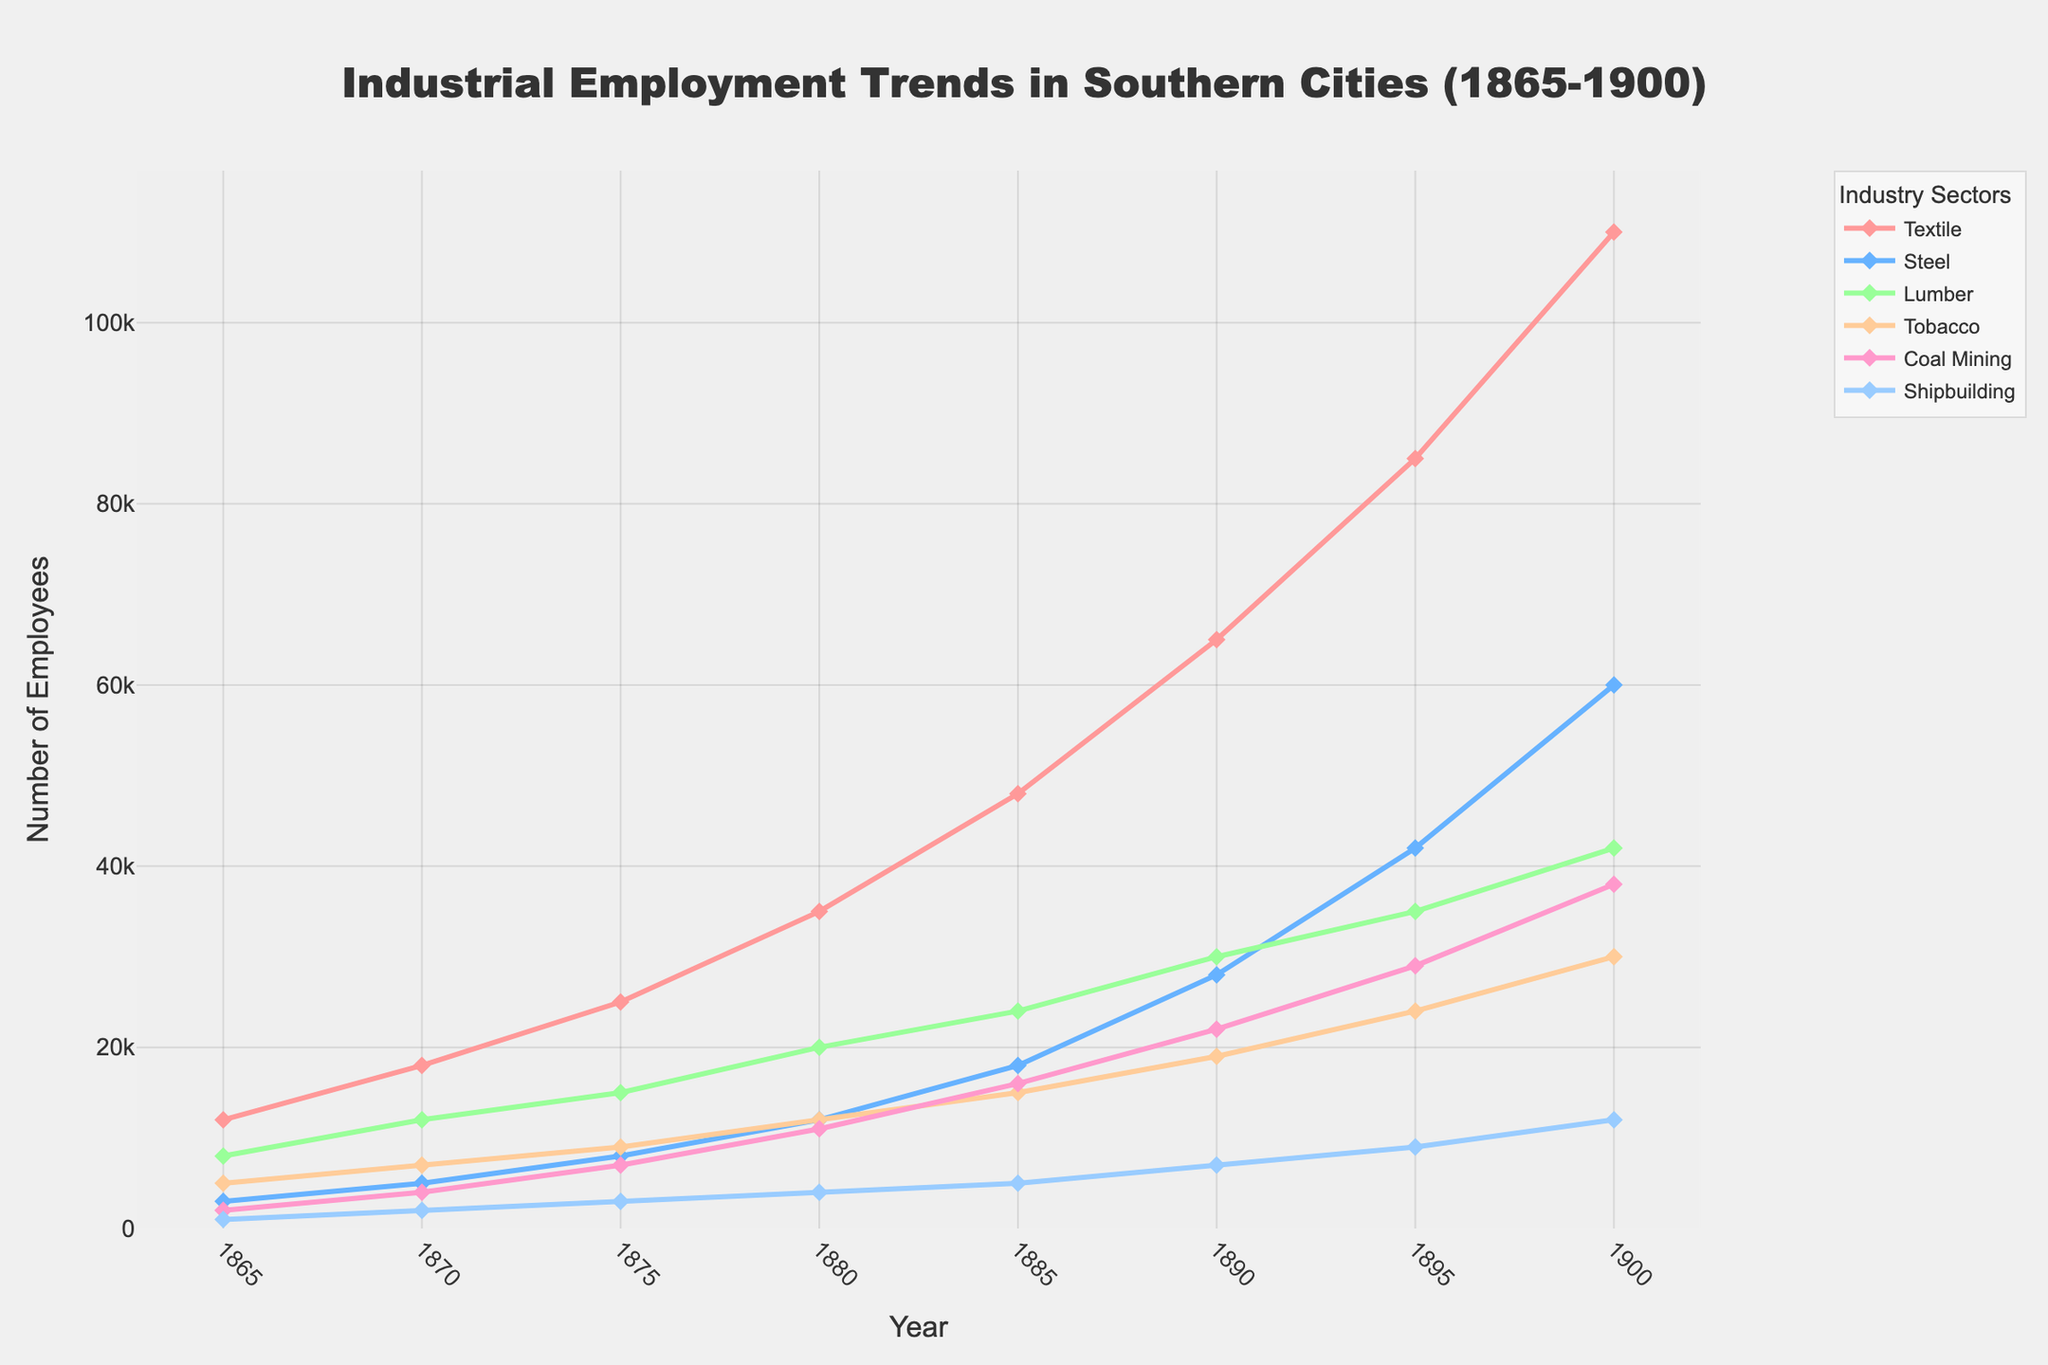What's the difference in the number of Textile and Lumber employees in 1900? In the year 1900, the Textile sector had 110,000 employees, and the Lumber sector had 42,000 employees. The difference is calculated as 110,000 - 42,000 = 68,000.
Answer: 68,000 Which sector saw the largest increase in employment from 1865 to 1900? To determine the sector with the largest increase, we subtract the 1865 employment numbers from the 1900 employment numbers for each sector. Textile: 110,000 - 12,000 = 98,000; Steel: 60,000 - 3,000 = 57,000; Lumber: 42,000 - 8,000 = 34,000; Tobacco: 30,000 - 5,000 = 25,000; Coal Mining: 38,000 - 2,000 = 36,000; Shipbuilding: 12,000 - 1,000 = 11,000. The Textile sector saw the largest increase of 98,000.
Answer: Textile During which decade did the Textile sector experience the most rapid growth? To find the decade with the most rapid growth, we look at the increase in employment numbers for each decade. 1865-1870: 18,000 - 12,000 = 6,000; 1870-1880: 35,000 - 18,000 = 17,000; 1880-1890: 65,000 - 35,000 = 30,000; 1890-1900: 110,000 - 65,000 = 45,000. The Textile sector saw the most rapid growth during the 1890-1900 decade with an increase of 45,000.
Answer: 1890-1900 How many more employees were there in the Steel sector than in the Coal Mining sector in 1890? In 1890, the Steel sector had 28,000 employees, and the Coal Mining sector had 22,000 employees. The difference is calculated as 28,000 - 22,000 = 6,000.
Answer: 6,000 Compare employment in the Tobacco sector between 1885 and 1900. Did the number of employees increase or decrease, and by how much? In 1885, the Tobacco sector had 15,000 employees, and in 1900, it had 30,000 employees. The number of employees increased by 30,000 - 15,000 = 15,000.
Answer: Increase, 15,000 In 1875, which sector had the smallest number of employees? Referring to the 1875 data, the sector with the smallest number of employees is Shipbuilding with 3,000 employees.
Answer: Shipbuilding What is the average number of employees across all sectors in 1875? To calculate the average, sum the employment numbers for each sector in 1875 and then divide by the number of sectors. (25,000 + 8,000 + 15,000 + 9,000 + 7,000 + 3,000) / 6 = 67,000 / 6 = 11,167.
Answer: 11,167 Between 1870 and 1880, which sector had the highest growth in employment? Calculate the growth for each sector between 1870 and 1880. Textile: 35,000 - 18,000 = 17,000; Steel: 12,000 - 5,000 = 7,000; Lumber: 20,000 - 12,000 = 8,000; Tobacco: 12,000 - 7,000 = 5,000; Coal Mining: 11,000 - 4,000 = 7,000; Shipbuilding: 4,000 - 2,000 = 2,000. The Textile sector had the highest growth with 17,000 employees.
Answer: Textile 